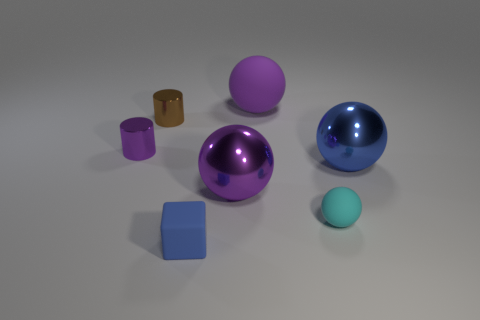Are there any spheres of the same size as the cyan matte object?
Provide a short and direct response. No. What is the material of the cyan object that is the same size as the blue cube?
Ensure brevity in your answer.  Rubber. There is a blue sphere that is behind the small rubber object that is behind the blue rubber cube; what size is it?
Offer a very short reply. Large. There is a rubber ball that is behind the brown cylinder; is it the same size as the blue block?
Offer a very short reply. No. Is the number of small brown cylinders that are behind the large matte sphere greater than the number of cyan balls on the right side of the small purple thing?
Offer a terse response. No. The thing that is both behind the small cyan sphere and to the right of the large rubber ball has what shape?
Provide a short and direct response. Sphere. There is a large purple metallic object that is right of the tiny blue rubber object; what is its shape?
Keep it short and to the point. Sphere. There is a rubber sphere right of the purple ball behind the blue thing that is behind the small rubber ball; how big is it?
Offer a very short reply. Small. Is the shape of the brown metal object the same as the tiny cyan rubber thing?
Offer a very short reply. No. There is a rubber object that is in front of the big rubber sphere and left of the tiny cyan ball; how big is it?
Offer a very short reply. Small. 